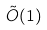Convert formula to latex. <formula><loc_0><loc_0><loc_500><loc_500>\tilde { O } ( 1 )</formula> 